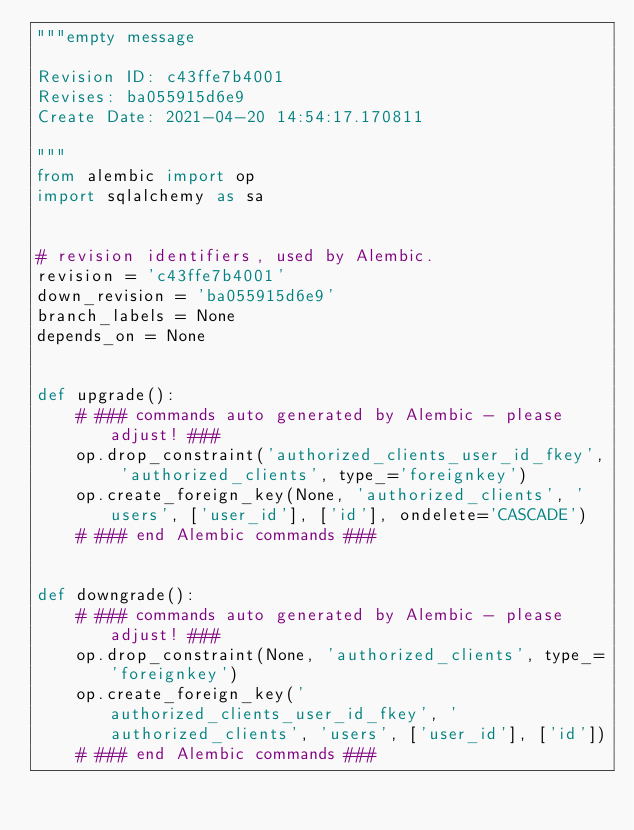<code> <loc_0><loc_0><loc_500><loc_500><_Python_>"""empty message

Revision ID: c43ffe7b4001
Revises: ba055915d6e9
Create Date: 2021-04-20 14:54:17.170811

"""
from alembic import op
import sqlalchemy as sa


# revision identifiers, used by Alembic.
revision = 'c43ffe7b4001'
down_revision = 'ba055915d6e9'
branch_labels = None
depends_on = None


def upgrade():
    # ### commands auto generated by Alembic - please adjust! ###
    op.drop_constraint('authorized_clients_user_id_fkey', 'authorized_clients', type_='foreignkey')
    op.create_foreign_key(None, 'authorized_clients', 'users', ['user_id'], ['id'], ondelete='CASCADE')
    # ### end Alembic commands ###


def downgrade():
    # ### commands auto generated by Alembic - please adjust! ###
    op.drop_constraint(None, 'authorized_clients', type_='foreignkey')
    op.create_foreign_key('authorized_clients_user_id_fkey', 'authorized_clients', 'users', ['user_id'], ['id'])
    # ### end Alembic commands ###
</code> 